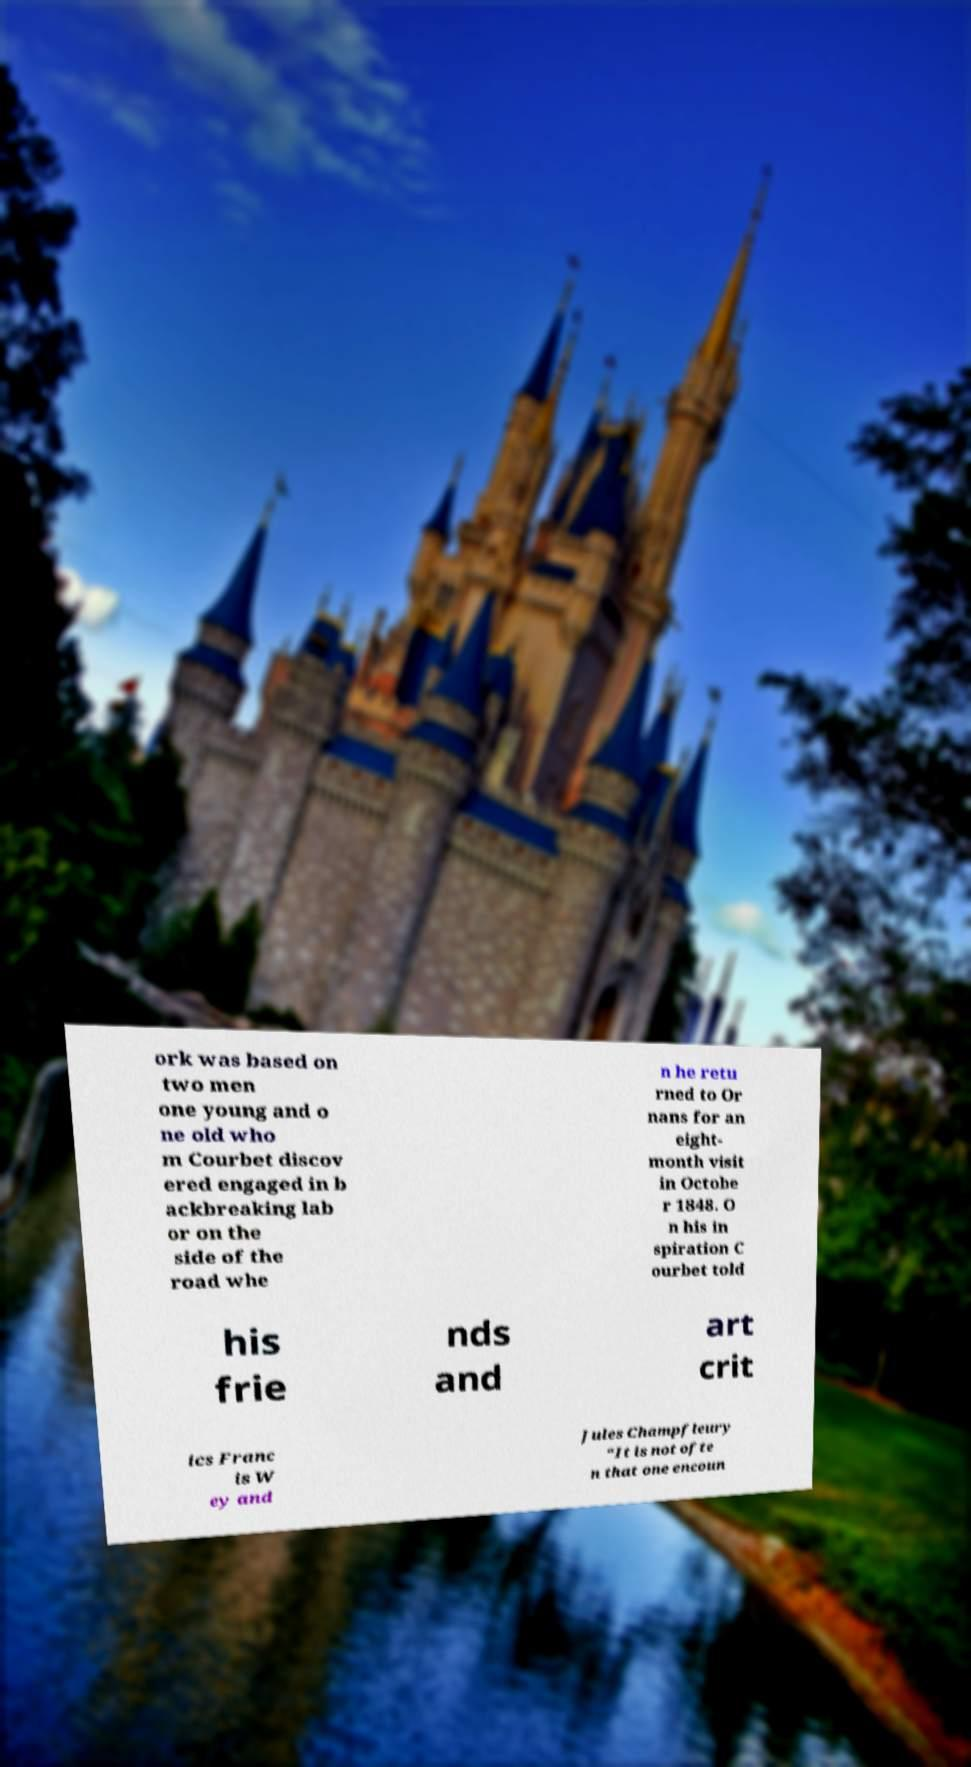Could you assist in decoding the text presented in this image and type it out clearly? ork was based on two men one young and o ne old who m Courbet discov ered engaged in b ackbreaking lab or on the side of the road whe n he retu rned to Or nans for an eight- month visit in Octobe r 1848. O n his in spiration C ourbet told his frie nds and art crit ics Franc is W ey and Jules Champfleury “It is not ofte n that one encoun 